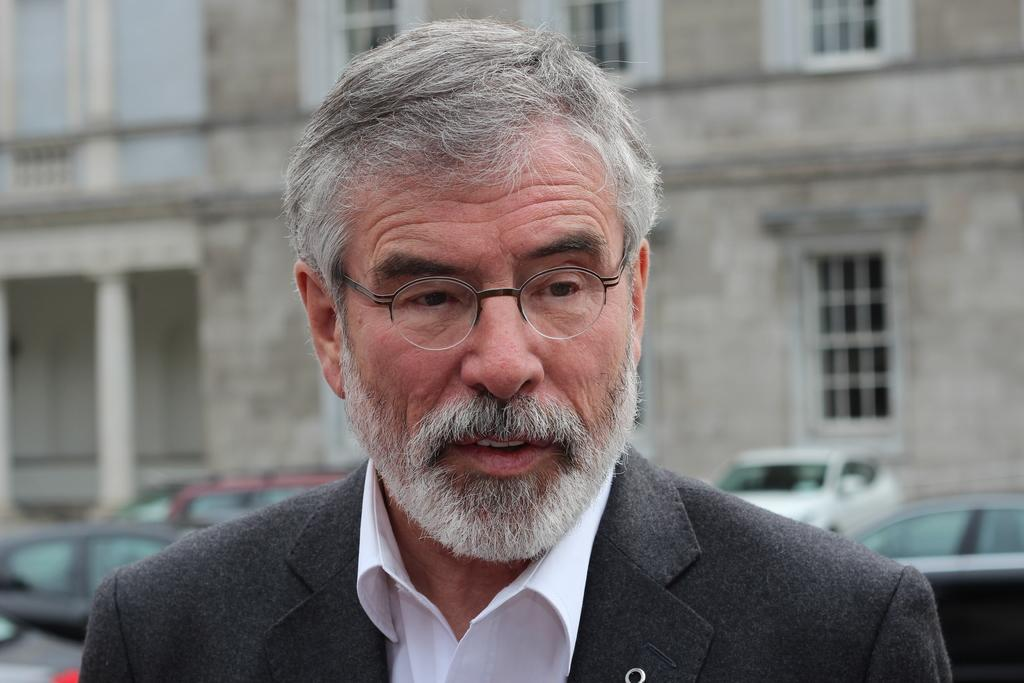What is the main subject in the foreground of the image? There is a man in the foreground of the image. What is the man doing in the image? The man is talking. What can be seen in the background of the image? There is a building and vehicles in the background of the image. What type of polish is the man applying to his shoes in the image? There is no indication in the image that the man is applying any polish to his shoes, as he is talking and not performing any such action. 